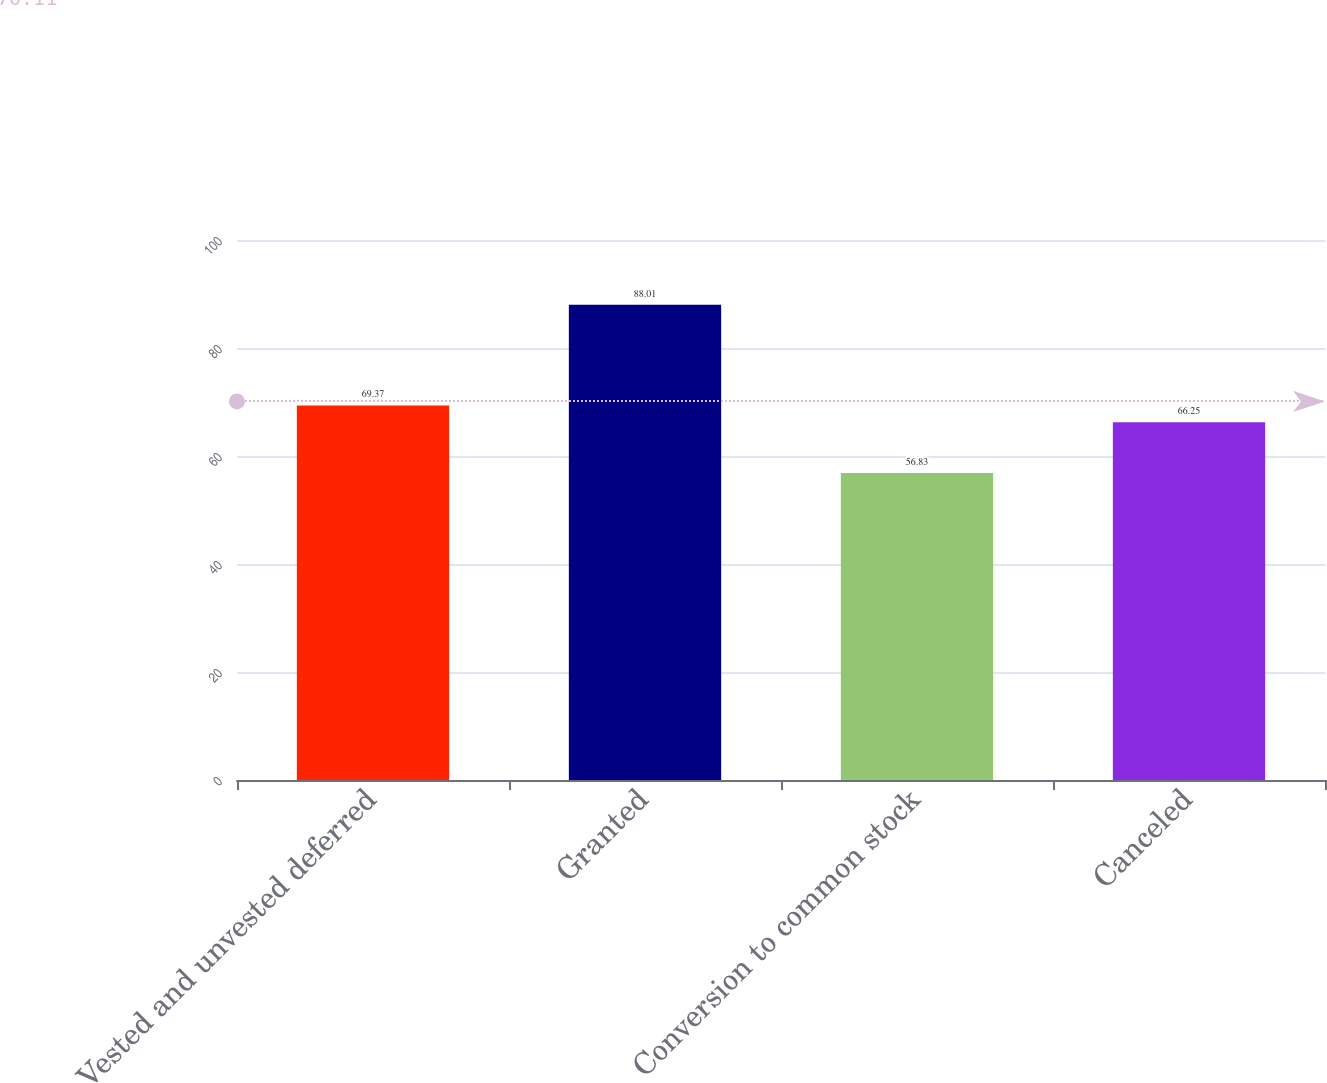Convert chart. <chart><loc_0><loc_0><loc_500><loc_500><bar_chart><fcel>Vested and unvested deferred<fcel>Granted<fcel>Conversion to common stock<fcel>Canceled<nl><fcel>69.37<fcel>88.01<fcel>56.83<fcel>66.25<nl></chart> 